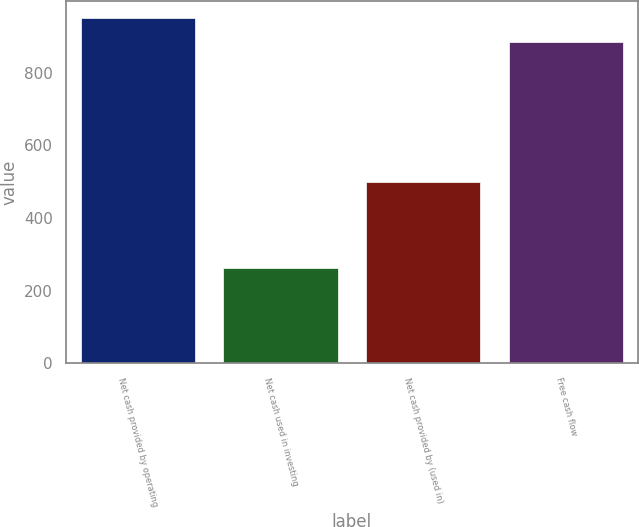<chart> <loc_0><loc_0><loc_500><loc_500><bar_chart><fcel>Net cash provided by operating<fcel>Net cash used in investing<fcel>Net cash provided by (used in)<fcel>Free cash flow<nl><fcel>950.99<fcel>261.9<fcel>498.8<fcel>884.5<nl></chart> 